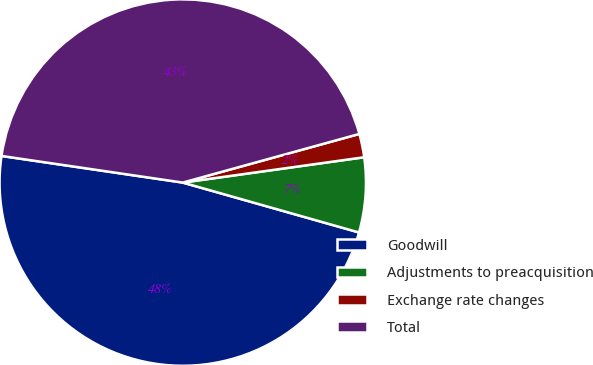<chart> <loc_0><loc_0><loc_500><loc_500><pie_chart><fcel>Goodwill<fcel>Adjustments to preacquisition<fcel>Exchange rate changes<fcel>Total<nl><fcel>47.93%<fcel>6.6%<fcel>2.07%<fcel>43.4%<nl></chart> 